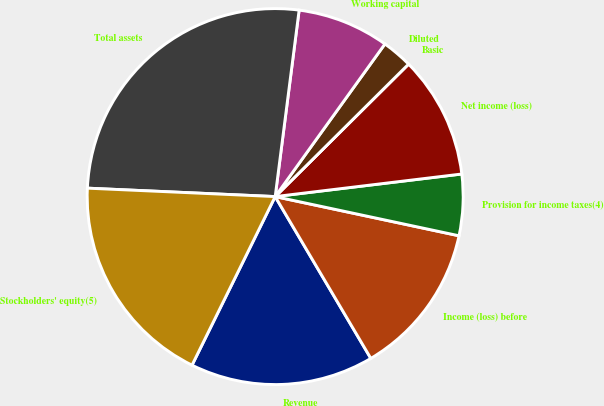Convert chart. <chart><loc_0><loc_0><loc_500><loc_500><pie_chart><fcel>Revenue<fcel>Income (loss) before<fcel>Provision for income taxes(4)<fcel>Net income (loss)<fcel>Basic<fcel>Diluted<fcel>Working capital<fcel>Total assets<fcel>Stockholders' equity(5)<nl><fcel>15.79%<fcel>13.16%<fcel>5.26%<fcel>10.53%<fcel>0.0%<fcel>2.63%<fcel>7.89%<fcel>26.32%<fcel>18.42%<nl></chart> 